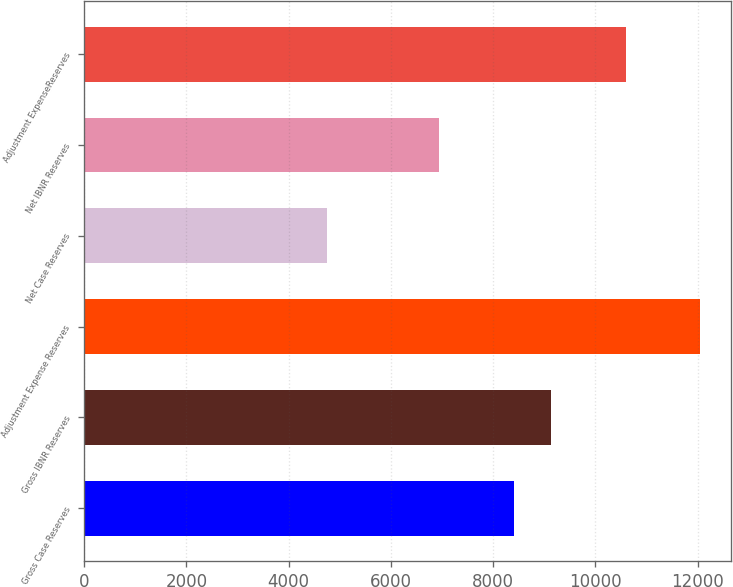Convert chart to OTSL. <chart><loc_0><loc_0><loc_500><loc_500><bar_chart><fcel>Gross Case Reserves<fcel>Gross IBNR Reserves<fcel>Adjustment Expense Reserves<fcel>Net Case Reserves<fcel>Net IBNR Reserves<fcel>Adjustment ExpenseReserves<nl><fcel>8399<fcel>9128.8<fcel>12048<fcel>4750<fcel>6939.4<fcel>10588.4<nl></chart> 